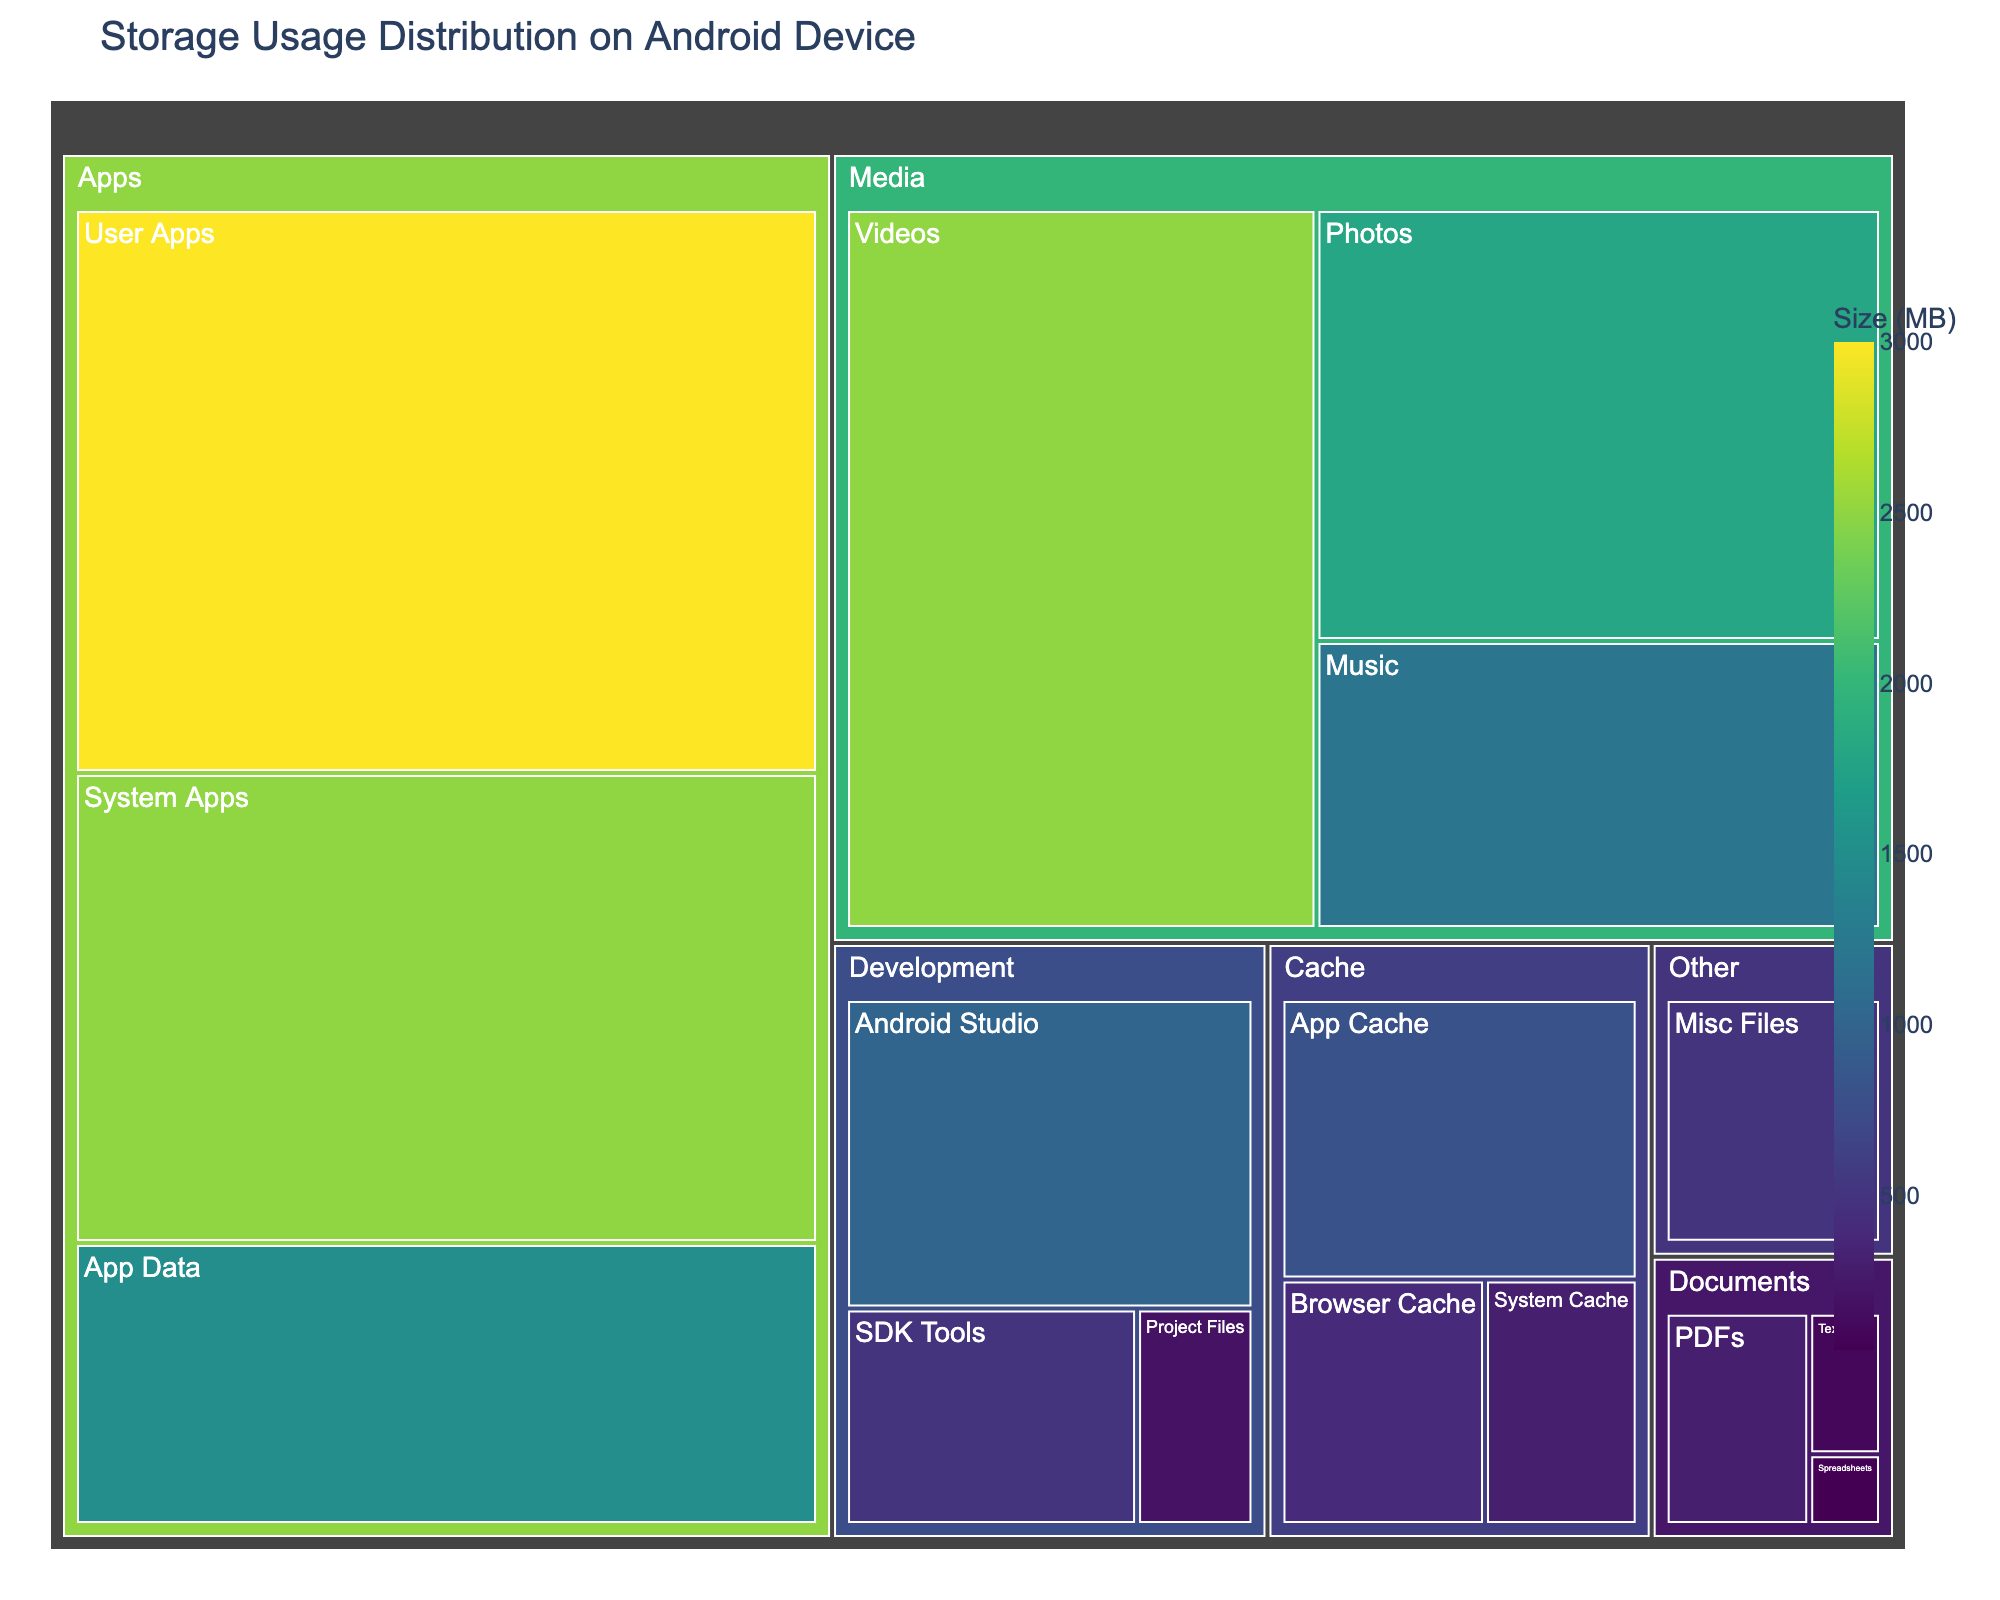What is the title of the treemap? The title of the figure is generally found at the top and typically provides a summary of what the figure is about. Here, the title is clearly stated at the top of the figure.
Answer: Storage Usage Distribution on Android Device Which category occupies the most storage space? To determine which category occupies the most space, you need to look at the area of the rectangles representing each category. The largest rectangle corresponds to the largest storage usage.
Answer: Apps What is the total storage usage of the Media category? Add the sizes of all subcategories under Media. Photos: 1800 MB, Videos: 2500 MB, Music: 1200 MB. So, 1800 + 2500 + 1200.
Answer: 5500 MB Is the storage used by Development files greater than Cache files? Compare the total storage used by Development (1000 MB + 500 MB + 200 MB) and Cache (800 MB + 400 MB + 300 MB). Development: 1700 MB and Cache: 1500 MB.
Answer: Yes Which subcategory under Documents uses the least space? Look at the sizes of the subcategories under Documents. PDFs: 300 MB, Text Files: 100 MB, Spreadsheets: 50 MB. The smallest rectangle corresponds to the smallest storage usage.
Answer: Spreadsheets How much more storage does User Apps use compared to System Apps? Subtract the storage used by System Apps from the storage used by User Apps. User Apps: 3000 MB, System Apps: 2500 MB. So, 3000 - 2500.
Answer: 500 MB Which subcategory of Apps takes up the smallest space? Look at the sizes of the subcategories under Apps. System Apps: 2500 MB, User Apps: 3000 MB, App Data: 1500 MB. The smallest rectangle corresponds to the smallest storage usage.
Answer: App Data What is the combined storage usage of the Cache and Other categories? Add the total sizes of Cache and Other categories. Cache: 800 MB + 400 MB + 300 MB and Other: 500 MB. So, 1500 + 500.
Answer: 2000 MB Is the storage used by Photos more than the storage used by PDFs and Text Files combined? Compare the storage used by Photos (1800 MB) and the sum of PDFs (300 MB) and Text Files (100 MB). So, 1800 MB vs. 400 MB.
Answer: Yes Which category uses the most storage within the App category? Compare the storage usage of the subcategories under Apps: System Apps: 2500 MB, User Apps: 3000 MB, App Data: 1500 MB. The largest rectangle corresponds to the largest storage usage.
Answer: User Apps 